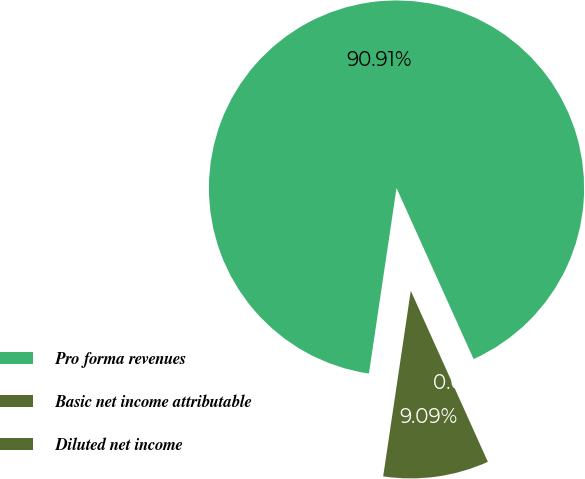<chart> <loc_0><loc_0><loc_500><loc_500><pie_chart><fcel>Pro forma revenues<fcel>Basic net income attributable<fcel>Diluted net income<nl><fcel>90.91%<fcel>9.09%<fcel>0.0%<nl></chart> 